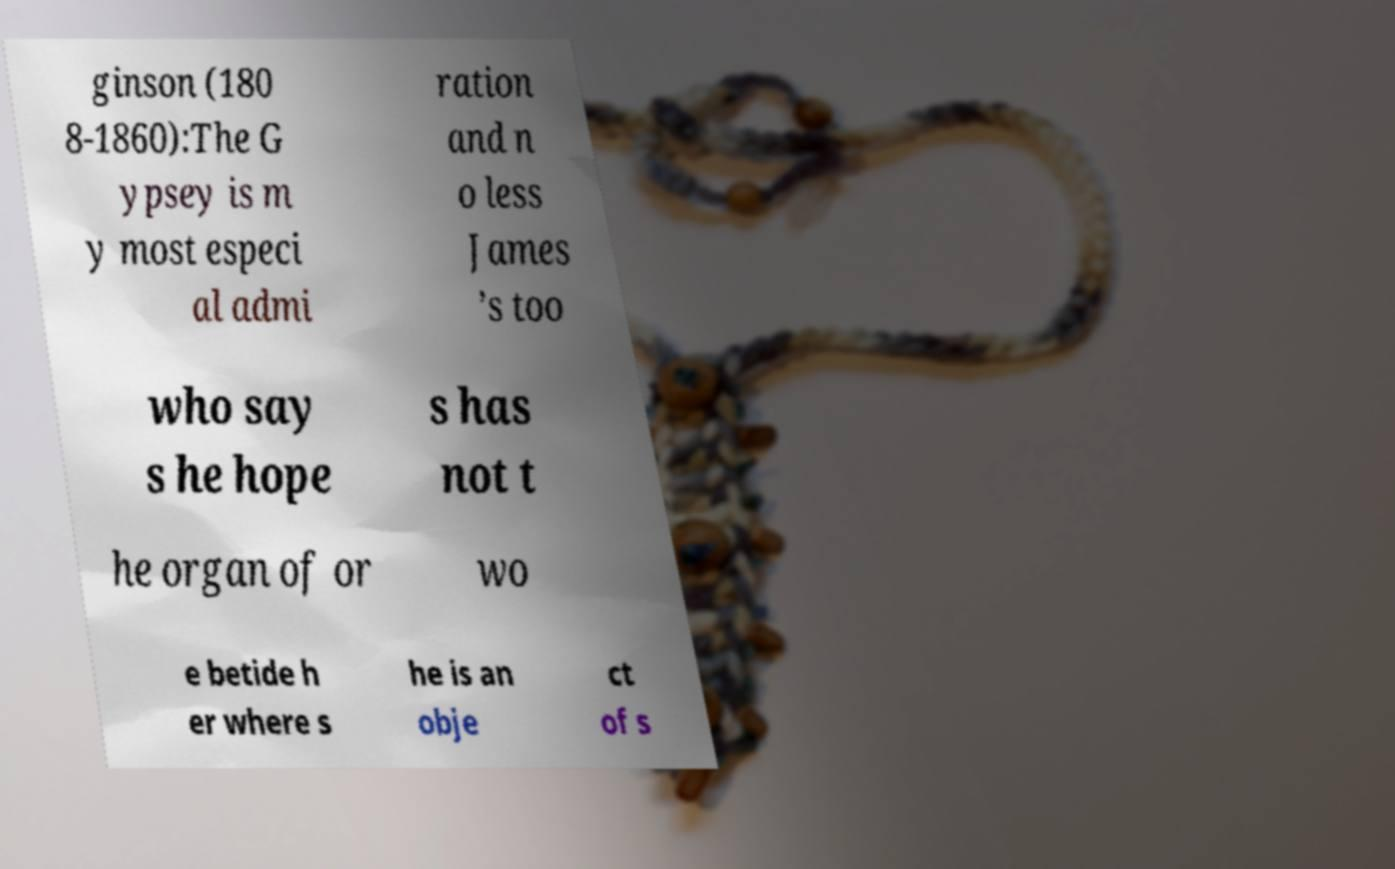Can you read and provide the text displayed in the image?This photo seems to have some interesting text. Can you extract and type it out for me? ginson (180 8-1860):The G ypsey is m y most especi al admi ration and n o less James ’s too who say s he hope s has not t he organ of or wo e betide h er where s he is an obje ct of s 